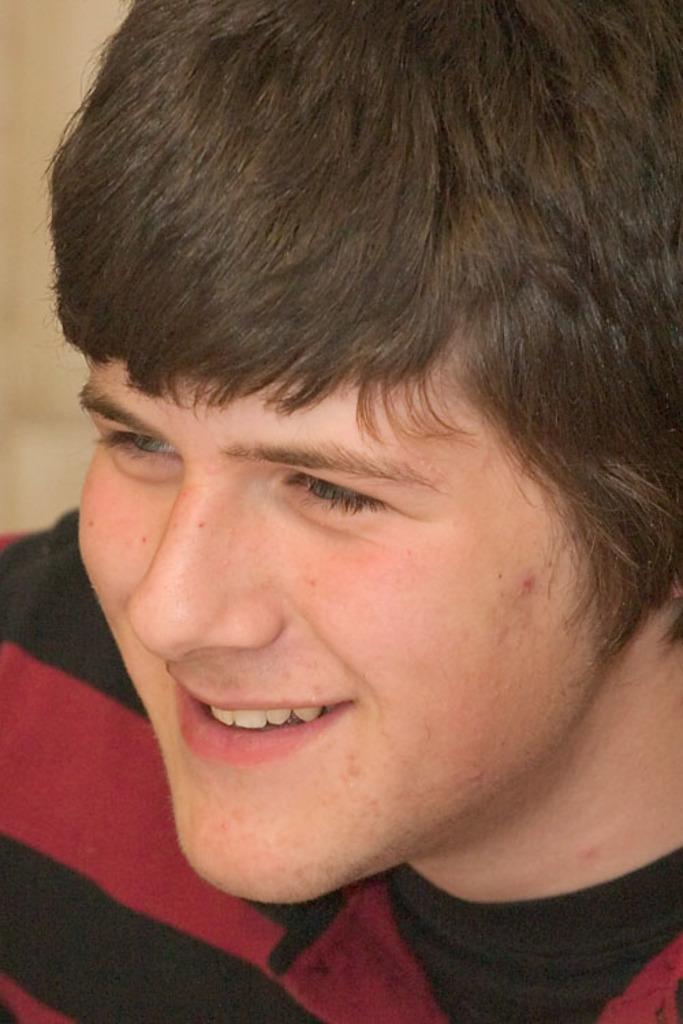Please provide a concise description of this image. In this image we can see a person wearing a dress. 